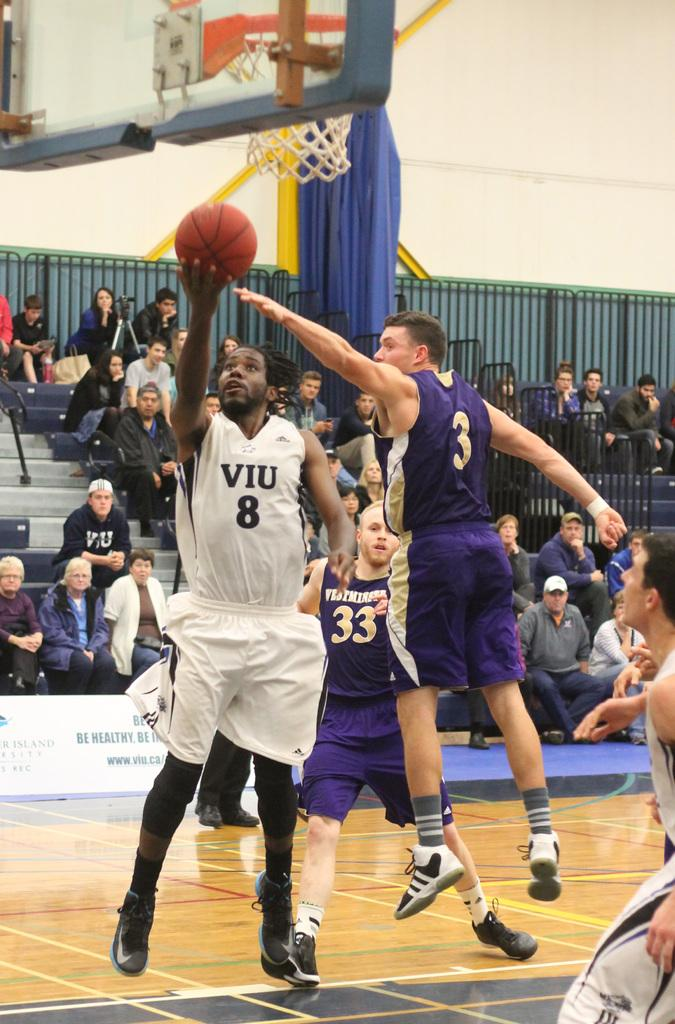<image>
Describe the image concisely. VIU number 8 attempting to shoot a basketball into the basket 